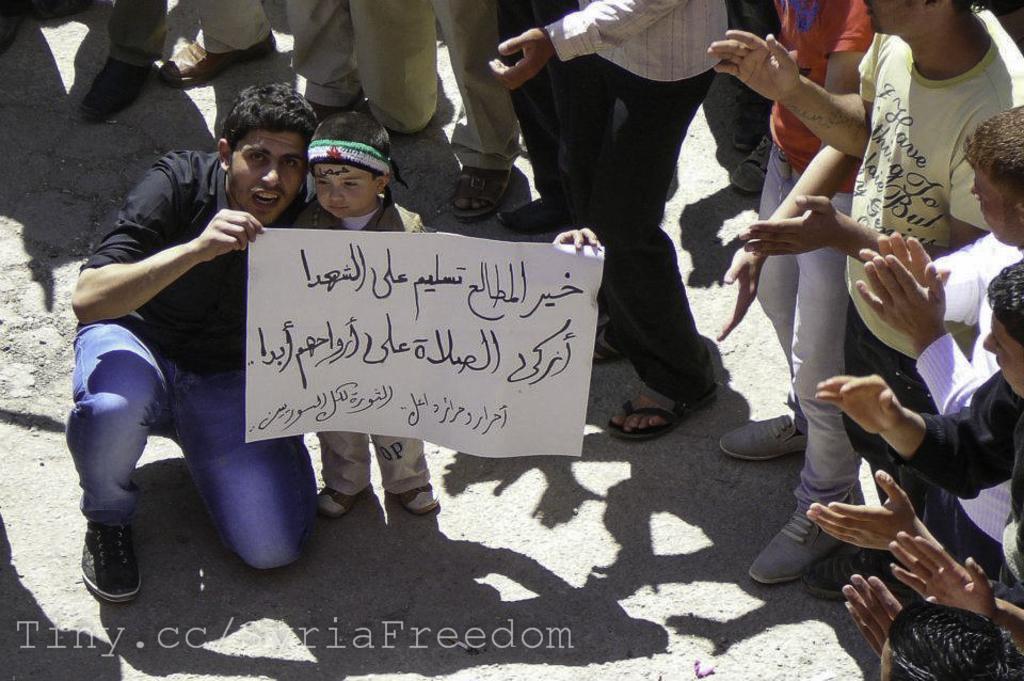How would you summarize this image in a sentence or two? In this picture I can see a kid standing, there is a man holding a paper, there are group of people standing, and there is a watermark on the image. 